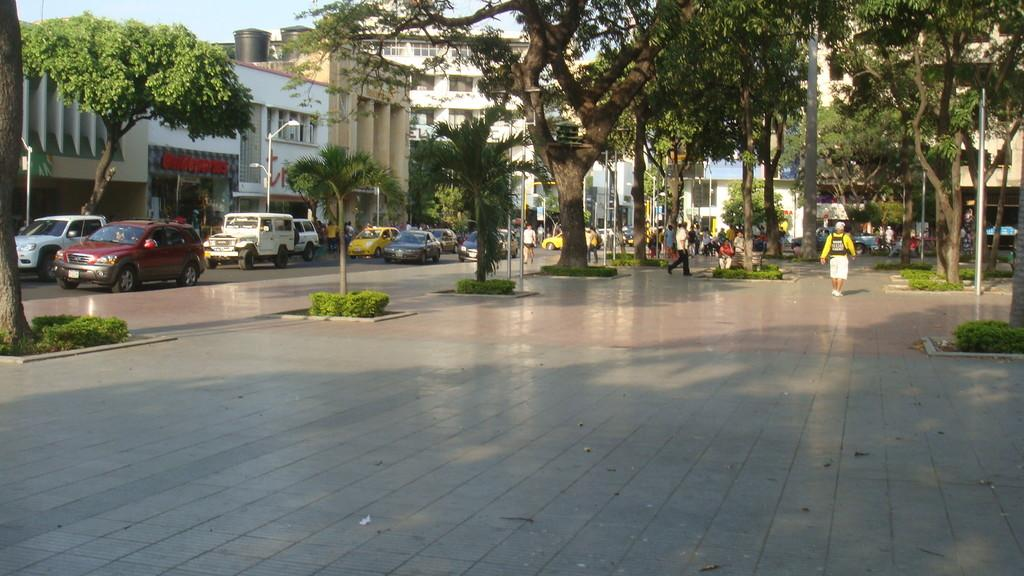What is in the foreground of the image? There is pavement in the foreground of the image. What can be seen in the background of the image? There are trees, poles, people, buildings, and the sky visible in the background of the image. What type of test is being conducted on the pavement in the image? There is no test being conducted on the pavement in the image. The image simply shows pavement in the foreground and various elements in the background. 